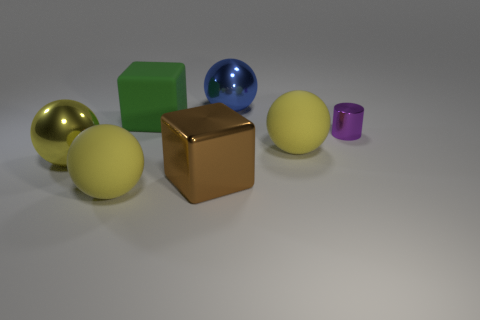What size is the purple thing that is to the right of the large matte sphere that is to the right of the large block in front of the small purple shiny thing?
Offer a very short reply. Small. There is a metal cylinder; are there any cubes behind it?
Your answer should be compact. Yes. What number of things are either big yellow matte objects left of the blue object or large purple matte cylinders?
Your response must be concise. 1. There is a purple object that is the same material as the big brown object; what size is it?
Provide a short and direct response. Small. Do the matte block and the cylinder behind the big brown metallic object have the same size?
Ensure brevity in your answer.  No. What color is the rubber object that is in front of the tiny metallic thing and to the left of the big blue ball?
Give a very brief answer. Yellow. How many objects are either large spheres that are in front of the shiny cylinder or metallic objects behind the yellow metallic sphere?
Your answer should be very brief. 5. What is the color of the shiny ball in front of the rubber ball on the right side of the sphere that is behind the big green object?
Your answer should be compact. Yellow. Is there a large green matte thing of the same shape as the large brown object?
Provide a short and direct response. Yes. How many tiny purple shiny things are there?
Your answer should be very brief. 1. 